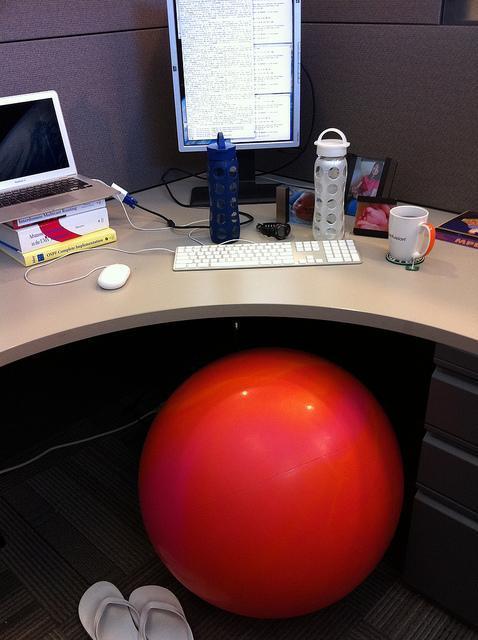How many water bottles are there?
Give a very brief answer. 2. How many bottles are there?
Give a very brief answer. 2. How many sports balls are there?
Give a very brief answer. 1. 